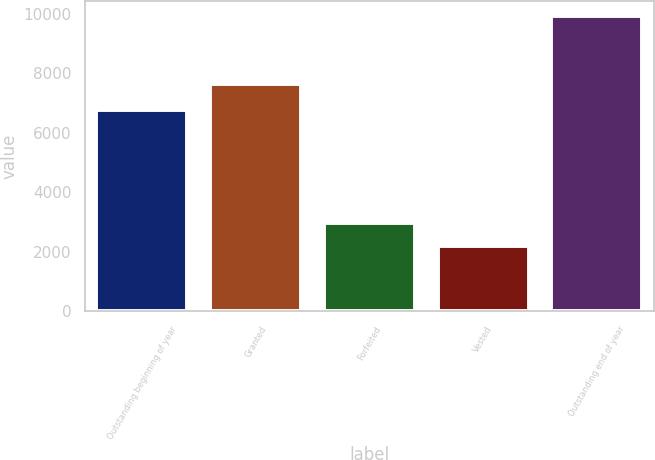Convert chart to OTSL. <chart><loc_0><loc_0><loc_500><loc_500><bar_chart><fcel>Outstanding beginning of year<fcel>Granted<fcel>Forfeited<fcel>Vested<fcel>Outstanding end of year<nl><fcel>6771<fcel>7630<fcel>2961.5<fcel>2188<fcel>9923<nl></chart> 